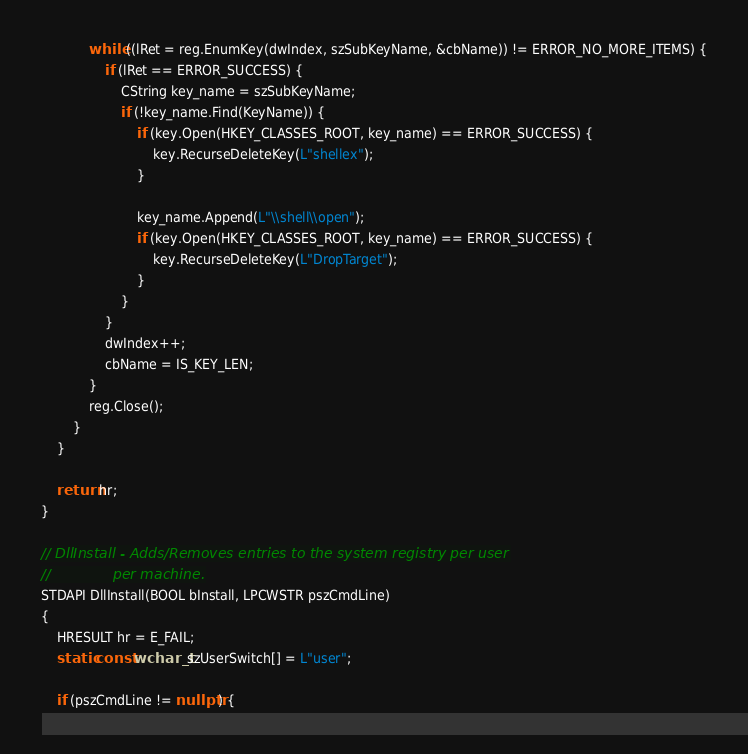Convert code to text. <code><loc_0><loc_0><loc_500><loc_500><_C++_>
			while ((lRet = reg.EnumKey(dwIndex, szSubKeyName, &cbName)) != ERROR_NO_MORE_ITEMS) {
				if (lRet == ERROR_SUCCESS) {
					CString key_name = szSubKeyName;
					if (!key_name.Find(KeyName)) {
						if (key.Open(HKEY_CLASSES_ROOT, key_name) == ERROR_SUCCESS) {
							key.RecurseDeleteKey(L"shellex");
						}

						key_name.Append(L"\\shell\\open");
						if (key.Open(HKEY_CLASSES_ROOT, key_name) == ERROR_SUCCESS) {
							key.RecurseDeleteKey(L"DropTarget");
						}
					}
				}
				dwIndex++;
				cbName = IS_KEY_LEN;
			}
			reg.Close();
		}
	}

	return hr;
}

// DllInstall - Adds/Removes entries to the system registry per user
//              per machine.
STDAPI DllInstall(BOOL bInstall, LPCWSTR pszCmdLine)
{
	HRESULT hr = E_FAIL;
	static const wchar_t szUserSwitch[] = L"user";

	if (pszCmdLine != nullptr) {</code> 